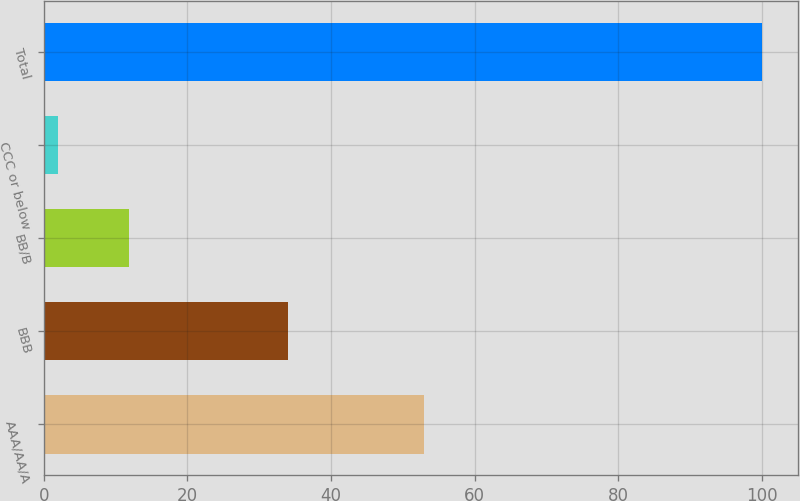Convert chart. <chart><loc_0><loc_0><loc_500><loc_500><bar_chart><fcel>AAA/AA/A<fcel>BBB<fcel>BB/B<fcel>CCC or below<fcel>Total<nl><fcel>53<fcel>34<fcel>11.8<fcel>2<fcel>100<nl></chart> 